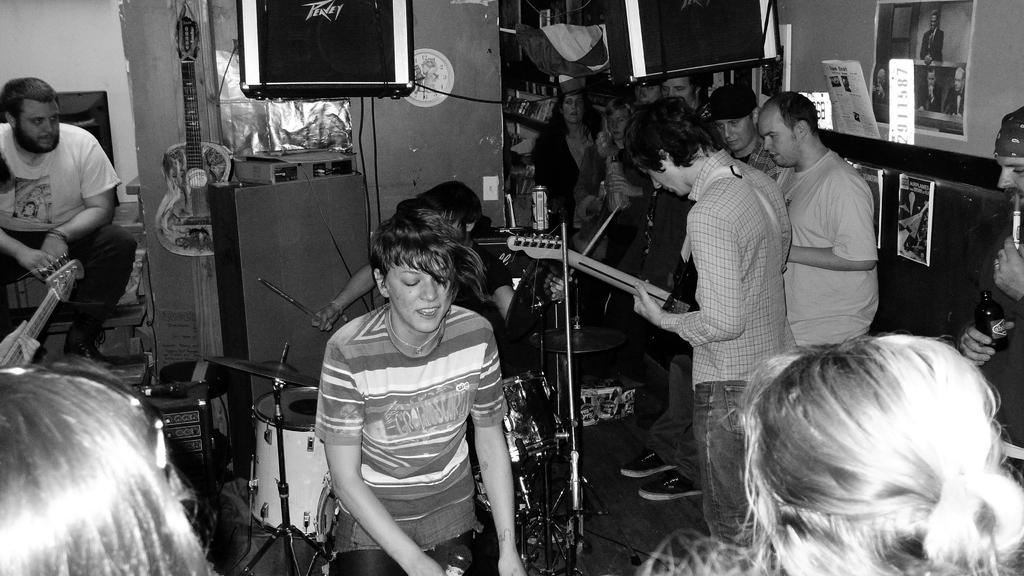Can you describe this image briefly? This picture describe about a group of boys and girls who is performing a musical show in the room, Center we can see a girl singing in the microphone and on the behind a person sitting and playing a band. On the extreme left we can see a person wearing white t-shirt and sitting. Right side we can sea group of people standing and watching the show. On wall we can see speaker, poster and guitar hanging. 